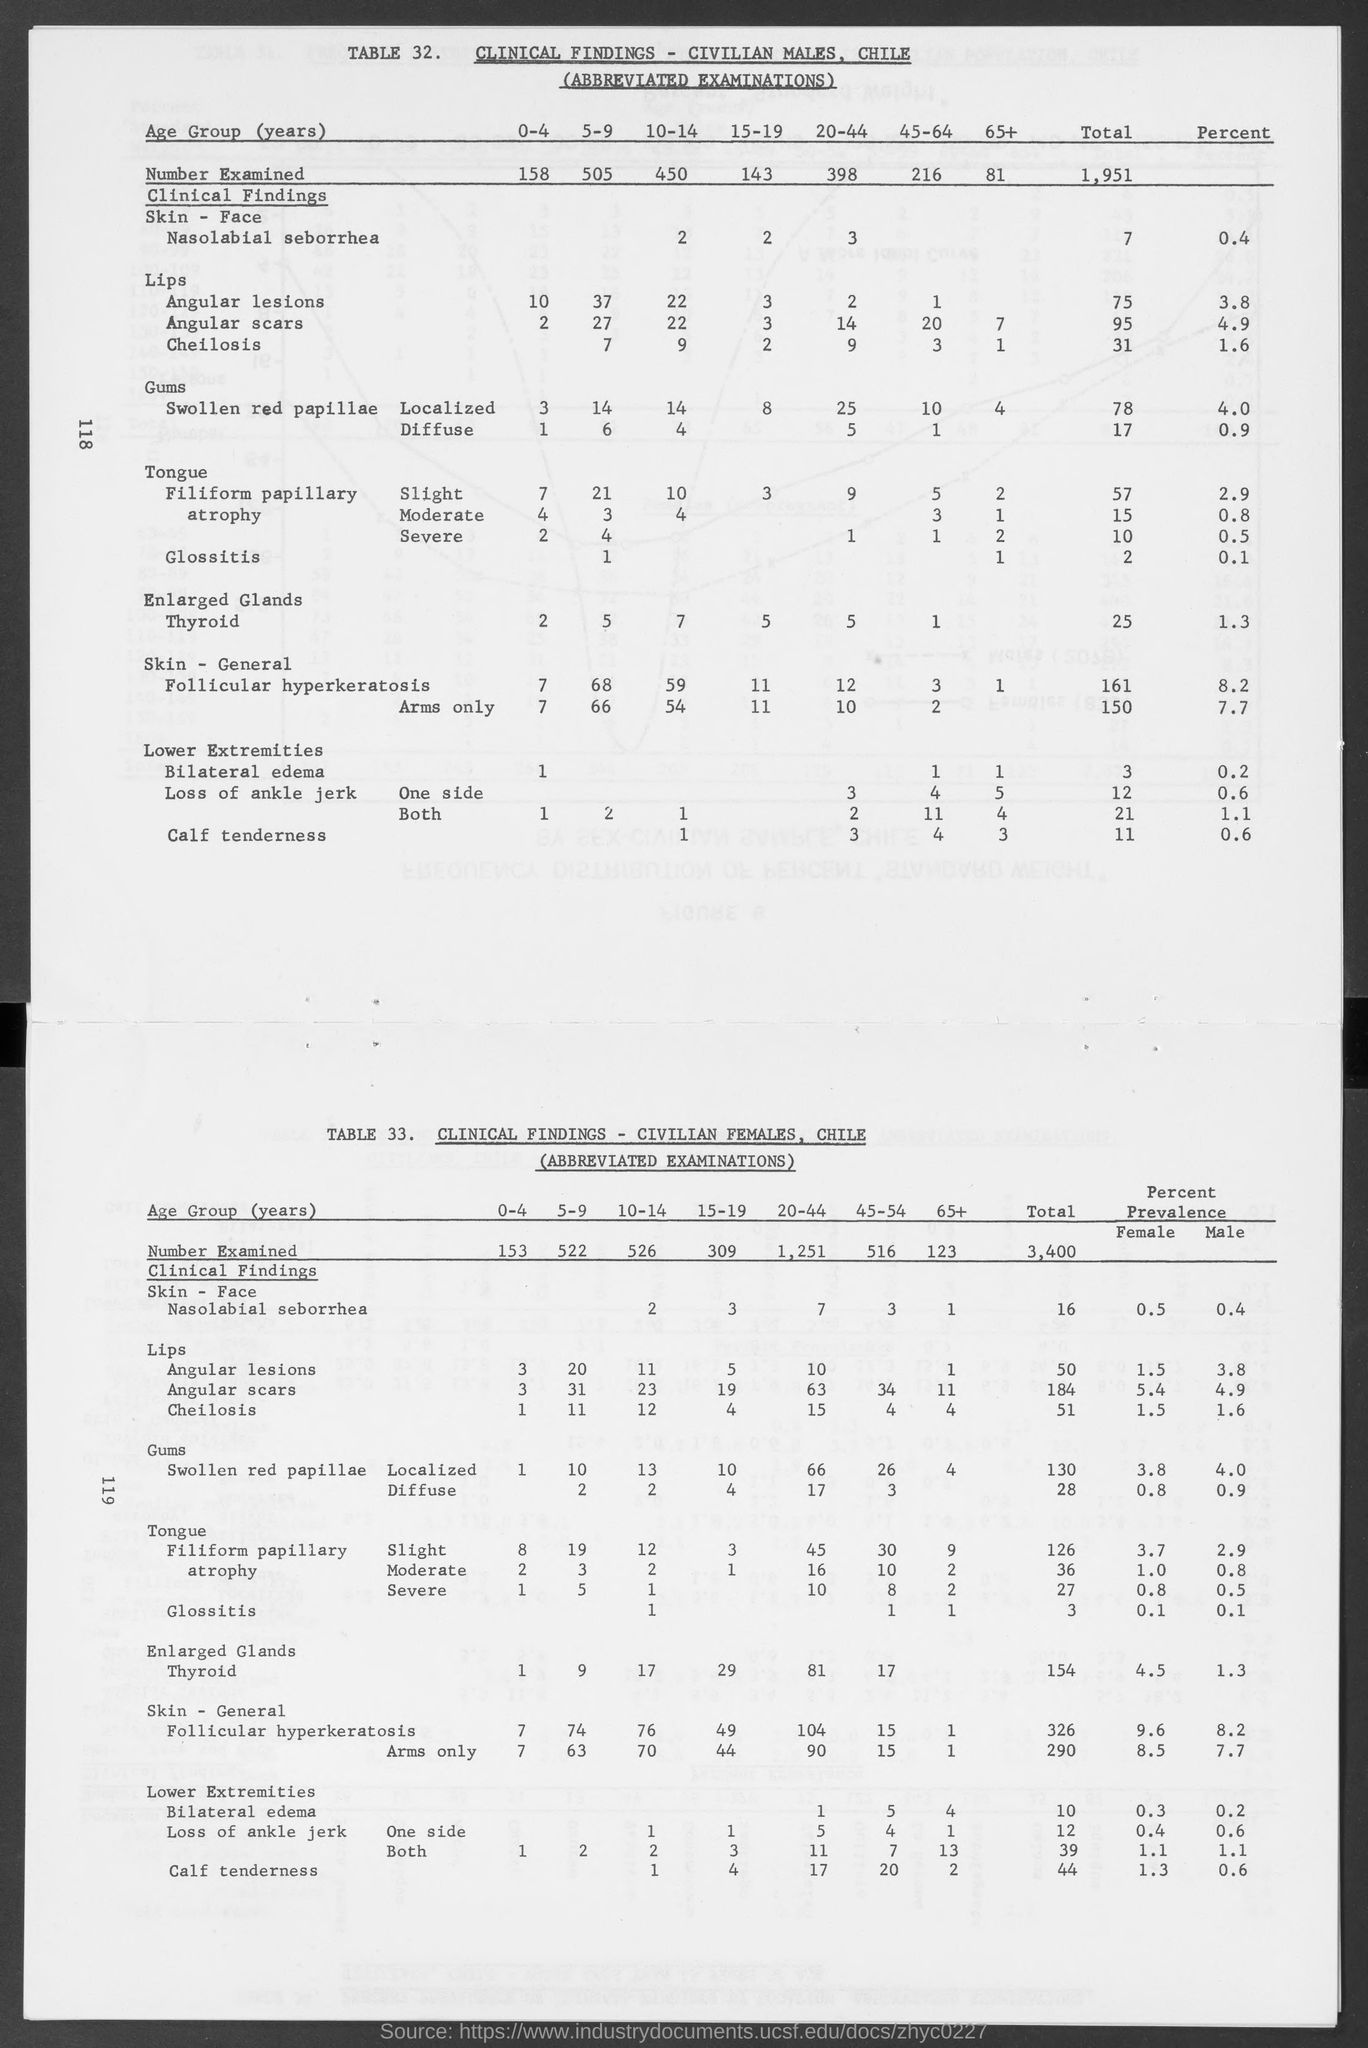Point out several critical features in this image. The number of examinations conducted for civilian males in Chile, for the age group 0-4 years, is 158. According to the examination of the number of civilian males in Chile for the age group of 20-44 years, the number that was examined is 398. In the age group of 10-14 years in Chile, 526 individuals were examined for Number. According to the data, the number of civilian males aged 65 and older in Chile was examined to be 81. In Chile, the number of civilian males aged 10-14 years examined was 450. 